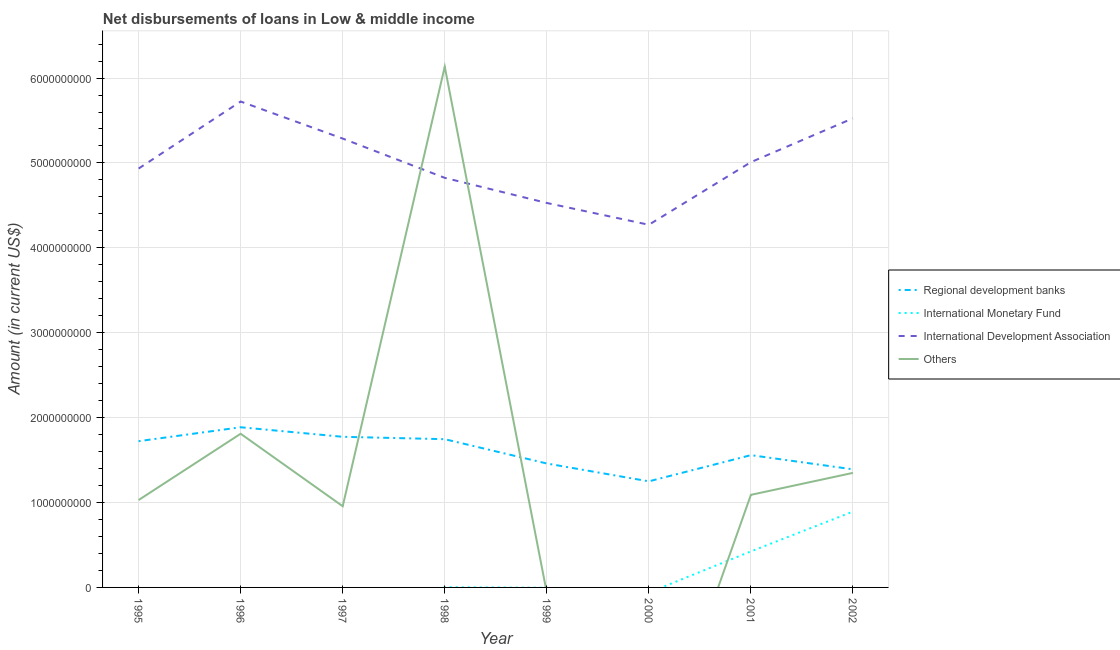How many different coloured lines are there?
Keep it short and to the point. 4. Is the number of lines equal to the number of legend labels?
Make the answer very short. No. What is the amount of loan disimbursed by regional development banks in 1995?
Make the answer very short. 1.72e+09. Across all years, what is the maximum amount of loan disimbursed by regional development banks?
Provide a short and direct response. 1.89e+09. Across all years, what is the minimum amount of loan disimbursed by other organisations?
Your answer should be compact. 0. What is the total amount of loan disimbursed by regional development banks in the graph?
Offer a terse response. 1.28e+1. What is the difference between the amount of loan disimbursed by regional development banks in 1995 and that in 1996?
Offer a very short reply. -1.64e+08. What is the difference between the amount of loan disimbursed by international development association in 2001 and the amount of loan disimbursed by international monetary fund in 1998?
Provide a succinct answer. 5.01e+09. What is the average amount of loan disimbursed by regional development banks per year?
Offer a very short reply. 1.60e+09. In the year 2002, what is the difference between the amount of loan disimbursed by international development association and amount of loan disimbursed by international monetary fund?
Ensure brevity in your answer.  4.63e+09. What is the ratio of the amount of loan disimbursed by international development association in 1998 to that in 2002?
Make the answer very short. 0.87. What is the difference between the highest and the second highest amount of loan disimbursed by international monetary fund?
Give a very brief answer. 4.69e+08. What is the difference between the highest and the lowest amount of loan disimbursed by international monetary fund?
Keep it short and to the point. 8.93e+08. Does the amount of loan disimbursed by international development association monotonically increase over the years?
Keep it short and to the point. No. Is the amount of loan disimbursed by regional development banks strictly greater than the amount of loan disimbursed by international development association over the years?
Your answer should be very brief. No. Is the amount of loan disimbursed by regional development banks strictly less than the amount of loan disimbursed by international monetary fund over the years?
Give a very brief answer. No. How many lines are there?
Offer a very short reply. 4. What is the difference between two consecutive major ticks on the Y-axis?
Your response must be concise. 1.00e+09. Are the values on the major ticks of Y-axis written in scientific E-notation?
Offer a terse response. No. How are the legend labels stacked?
Your answer should be very brief. Vertical. What is the title of the graph?
Ensure brevity in your answer.  Net disbursements of loans in Low & middle income. Does "Japan" appear as one of the legend labels in the graph?
Offer a terse response. No. What is the label or title of the X-axis?
Provide a succinct answer. Year. What is the label or title of the Y-axis?
Your answer should be very brief. Amount (in current US$). What is the Amount (in current US$) of Regional development banks in 1995?
Offer a very short reply. 1.72e+09. What is the Amount (in current US$) in International Monetary Fund in 1995?
Keep it short and to the point. 0. What is the Amount (in current US$) in International Development Association in 1995?
Your response must be concise. 4.93e+09. What is the Amount (in current US$) of Others in 1995?
Your answer should be compact. 1.03e+09. What is the Amount (in current US$) of Regional development banks in 1996?
Keep it short and to the point. 1.89e+09. What is the Amount (in current US$) of International Development Association in 1996?
Offer a terse response. 5.72e+09. What is the Amount (in current US$) of Others in 1996?
Your answer should be very brief. 1.81e+09. What is the Amount (in current US$) in Regional development banks in 1997?
Your response must be concise. 1.77e+09. What is the Amount (in current US$) in International Monetary Fund in 1997?
Give a very brief answer. 0. What is the Amount (in current US$) of International Development Association in 1997?
Ensure brevity in your answer.  5.29e+09. What is the Amount (in current US$) in Others in 1997?
Your answer should be compact. 9.57e+08. What is the Amount (in current US$) in Regional development banks in 1998?
Keep it short and to the point. 1.75e+09. What is the Amount (in current US$) of International Monetary Fund in 1998?
Give a very brief answer. 2.32e+06. What is the Amount (in current US$) in International Development Association in 1998?
Your answer should be very brief. 4.82e+09. What is the Amount (in current US$) in Others in 1998?
Your response must be concise. 6.13e+09. What is the Amount (in current US$) of Regional development banks in 1999?
Give a very brief answer. 1.46e+09. What is the Amount (in current US$) of International Development Association in 1999?
Offer a very short reply. 4.53e+09. What is the Amount (in current US$) in Others in 1999?
Offer a terse response. 0. What is the Amount (in current US$) in Regional development banks in 2000?
Your answer should be very brief. 1.25e+09. What is the Amount (in current US$) in International Development Association in 2000?
Offer a very short reply. 4.27e+09. What is the Amount (in current US$) of Regional development banks in 2001?
Your response must be concise. 1.56e+09. What is the Amount (in current US$) of International Monetary Fund in 2001?
Provide a succinct answer. 4.24e+08. What is the Amount (in current US$) of International Development Association in 2001?
Your answer should be very brief. 5.01e+09. What is the Amount (in current US$) of Others in 2001?
Provide a succinct answer. 1.09e+09. What is the Amount (in current US$) in Regional development banks in 2002?
Give a very brief answer. 1.39e+09. What is the Amount (in current US$) of International Monetary Fund in 2002?
Offer a very short reply. 8.93e+08. What is the Amount (in current US$) in International Development Association in 2002?
Offer a very short reply. 5.53e+09. What is the Amount (in current US$) in Others in 2002?
Provide a succinct answer. 1.35e+09. Across all years, what is the maximum Amount (in current US$) of Regional development banks?
Offer a very short reply. 1.89e+09. Across all years, what is the maximum Amount (in current US$) in International Monetary Fund?
Keep it short and to the point. 8.93e+08. Across all years, what is the maximum Amount (in current US$) in International Development Association?
Your answer should be very brief. 5.72e+09. Across all years, what is the maximum Amount (in current US$) in Others?
Your answer should be compact. 6.13e+09. Across all years, what is the minimum Amount (in current US$) in Regional development banks?
Make the answer very short. 1.25e+09. Across all years, what is the minimum Amount (in current US$) of International Monetary Fund?
Your response must be concise. 0. Across all years, what is the minimum Amount (in current US$) of International Development Association?
Make the answer very short. 4.27e+09. What is the total Amount (in current US$) of Regional development banks in the graph?
Ensure brevity in your answer.  1.28e+1. What is the total Amount (in current US$) of International Monetary Fund in the graph?
Make the answer very short. 1.32e+09. What is the total Amount (in current US$) in International Development Association in the graph?
Make the answer very short. 4.01e+1. What is the total Amount (in current US$) in Others in the graph?
Offer a very short reply. 1.24e+1. What is the difference between the Amount (in current US$) in Regional development banks in 1995 and that in 1996?
Provide a succinct answer. -1.64e+08. What is the difference between the Amount (in current US$) in International Development Association in 1995 and that in 1996?
Your response must be concise. -7.90e+08. What is the difference between the Amount (in current US$) of Others in 1995 and that in 1996?
Your answer should be compact. -7.81e+08. What is the difference between the Amount (in current US$) in Regional development banks in 1995 and that in 1997?
Your answer should be very brief. -5.16e+07. What is the difference between the Amount (in current US$) in International Development Association in 1995 and that in 1997?
Provide a short and direct response. -3.53e+08. What is the difference between the Amount (in current US$) of Others in 1995 and that in 1997?
Provide a succinct answer. 7.27e+07. What is the difference between the Amount (in current US$) in Regional development banks in 1995 and that in 1998?
Make the answer very short. -2.33e+07. What is the difference between the Amount (in current US$) of International Development Association in 1995 and that in 1998?
Provide a short and direct response. 1.09e+08. What is the difference between the Amount (in current US$) in Others in 1995 and that in 1998?
Make the answer very short. -5.11e+09. What is the difference between the Amount (in current US$) in Regional development banks in 1995 and that in 1999?
Give a very brief answer. 2.63e+08. What is the difference between the Amount (in current US$) in International Development Association in 1995 and that in 1999?
Give a very brief answer. 4.05e+08. What is the difference between the Amount (in current US$) in Regional development banks in 1995 and that in 2000?
Offer a terse response. 4.73e+08. What is the difference between the Amount (in current US$) in International Development Association in 1995 and that in 2000?
Your response must be concise. 6.62e+08. What is the difference between the Amount (in current US$) of Regional development banks in 1995 and that in 2001?
Give a very brief answer. 1.65e+08. What is the difference between the Amount (in current US$) in International Development Association in 1995 and that in 2001?
Your response must be concise. -7.55e+07. What is the difference between the Amount (in current US$) of Others in 1995 and that in 2001?
Provide a succinct answer. -6.12e+07. What is the difference between the Amount (in current US$) of Regional development banks in 1995 and that in 2002?
Your answer should be very brief. 3.32e+08. What is the difference between the Amount (in current US$) of International Development Association in 1995 and that in 2002?
Make the answer very short. -5.92e+08. What is the difference between the Amount (in current US$) of Others in 1995 and that in 2002?
Offer a very short reply. -3.20e+08. What is the difference between the Amount (in current US$) in Regional development banks in 1996 and that in 1997?
Offer a terse response. 1.12e+08. What is the difference between the Amount (in current US$) of International Development Association in 1996 and that in 1997?
Provide a short and direct response. 4.36e+08. What is the difference between the Amount (in current US$) in Others in 1996 and that in 1997?
Your answer should be compact. 8.54e+08. What is the difference between the Amount (in current US$) in Regional development banks in 1996 and that in 1998?
Offer a very short reply. 1.41e+08. What is the difference between the Amount (in current US$) of International Development Association in 1996 and that in 1998?
Offer a terse response. 8.99e+08. What is the difference between the Amount (in current US$) in Others in 1996 and that in 1998?
Offer a very short reply. -4.32e+09. What is the difference between the Amount (in current US$) in Regional development banks in 1996 and that in 1999?
Your response must be concise. 4.27e+08. What is the difference between the Amount (in current US$) in International Development Association in 1996 and that in 1999?
Give a very brief answer. 1.20e+09. What is the difference between the Amount (in current US$) in Regional development banks in 1996 and that in 2000?
Provide a short and direct response. 6.37e+08. What is the difference between the Amount (in current US$) in International Development Association in 1996 and that in 2000?
Your answer should be very brief. 1.45e+09. What is the difference between the Amount (in current US$) of Regional development banks in 1996 and that in 2001?
Offer a terse response. 3.28e+08. What is the difference between the Amount (in current US$) of International Development Association in 1996 and that in 2001?
Offer a very short reply. 7.14e+08. What is the difference between the Amount (in current US$) in Others in 1996 and that in 2001?
Offer a very short reply. 7.20e+08. What is the difference between the Amount (in current US$) in Regional development banks in 1996 and that in 2002?
Give a very brief answer. 4.96e+08. What is the difference between the Amount (in current US$) in International Development Association in 1996 and that in 2002?
Give a very brief answer. 1.98e+08. What is the difference between the Amount (in current US$) in Others in 1996 and that in 2002?
Your answer should be very brief. 4.61e+08. What is the difference between the Amount (in current US$) in Regional development banks in 1997 and that in 1998?
Your response must be concise. 2.83e+07. What is the difference between the Amount (in current US$) in International Development Association in 1997 and that in 1998?
Offer a very short reply. 4.63e+08. What is the difference between the Amount (in current US$) in Others in 1997 and that in 1998?
Offer a very short reply. -5.18e+09. What is the difference between the Amount (in current US$) of Regional development banks in 1997 and that in 1999?
Ensure brevity in your answer.  3.14e+08. What is the difference between the Amount (in current US$) of International Development Association in 1997 and that in 1999?
Your answer should be very brief. 7.59e+08. What is the difference between the Amount (in current US$) of Regional development banks in 1997 and that in 2000?
Give a very brief answer. 5.25e+08. What is the difference between the Amount (in current US$) in International Development Association in 1997 and that in 2000?
Provide a succinct answer. 1.02e+09. What is the difference between the Amount (in current US$) in Regional development banks in 1997 and that in 2001?
Your response must be concise. 2.16e+08. What is the difference between the Amount (in current US$) of International Development Association in 1997 and that in 2001?
Give a very brief answer. 2.78e+08. What is the difference between the Amount (in current US$) in Others in 1997 and that in 2001?
Keep it short and to the point. -1.34e+08. What is the difference between the Amount (in current US$) in Regional development banks in 1997 and that in 2002?
Ensure brevity in your answer.  3.83e+08. What is the difference between the Amount (in current US$) in International Development Association in 1997 and that in 2002?
Give a very brief answer. -2.39e+08. What is the difference between the Amount (in current US$) in Others in 1997 and that in 2002?
Your answer should be very brief. -3.93e+08. What is the difference between the Amount (in current US$) in Regional development banks in 1998 and that in 1999?
Keep it short and to the point. 2.86e+08. What is the difference between the Amount (in current US$) of International Development Association in 1998 and that in 1999?
Provide a succinct answer. 2.96e+08. What is the difference between the Amount (in current US$) in Regional development banks in 1998 and that in 2000?
Your answer should be compact. 4.96e+08. What is the difference between the Amount (in current US$) of International Development Association in 1998 and that in 2000?
Provide a short and direct response. 5.53e+08. What is the difference between the Amount (in current US$) in Regional development banks in 1998 and that in 2001?
Your response must be concise. 1.88e+08. What is the difference between the Amount (in current US$) in International Monetary Fund in 1998 and that in 2001?
Your response must be concise. -4.22e+08. What is the difference between the Amount (in current US$) of International Development Association in 1998 and that in 2001?
Your response must be concise. -1.85e+08. What is the difference between the Amount (in current US$) of Others in 1998 and that in 2001?
Make the answer very short. 5.04e+09. What is the difference between the Amount (in current US$) of Regional development banks in 1998 and that in 2002?
Make the answer very short. 3.55e+08. What is the difference between the Amount (in current US$) in International Monetary Fund in 1998 and that in 2002?
Ensure brevity in your answer.  -8.91e+08. What is the difference between the Amount (in current US$) in International Development Association in 1998 and that in 2002?
Keep it short and to the point. -7.01e+08. What is the difference between the Amount (in current US$) in Others in 1998 and that in 2002?
Your response must be concise. 4.79e+09. What is the difference between the Amount (in current US$) in Regional development banks in 1999 and that in 2000?
Ensure brevity in your answer.  2.10e+08. What is the difference between the Amount (in current US$) in International Development Association in 1999 and that in 2000?
Provide a short and direct response. 2.57e+08. What is the difference between the Amount (in current US$) in Regional development banks in 1999 and that in 2001?
Offer a terse response. -9.83e+07. What is the difference between the Amount (in current US$) of International Development Association in 1999 and that in 2001?
Offer a terse response. -4.81e+08. What is the difference between the Amount (in current US$) of Regional development banks in 1999 and that in 2002?
Make the answer very short. 6.87e+07. What is the difference between the Amount (in current US$) in International Development Association in 1999 and that in 2002?
Make the answer very short. -9.97e+08. What is the difference between the Amount (in current US$) in Regional development banks in 2000 and that in 2001?
Provide a short and direct response. -3.09e+08. What is the difference between the Amount (in current US$) in International Development Association in 2000 and that in 2001?
Provide a succinct answer. -7.38e+08. What is the difference between the Amount (in current US$) in Regional development banks in 2000 and that in 2002?
Provide a succinct answer. -1.42e+08. What is the difference between the Amount (in current US$) of International Development Association in 2000 and that in 2002?
Your response must be concise. -1.25e+09. What is the difference between the Amount (in current US$) in Regional development banks in 2001 and that in 2002?
Provide a short and direct response. 1.67e+08. What is the difference between the Amount (in current US$) of International Monetary Fund in 2001 and that in 2002?
Offer a terse response. -4.69e+08. What is the difference between the Amount (in current US$) in International Development Association in 2001 and that in 2002?
Give a very brief answer. -5.16e+08. What is the difference between the Amount (in current US$) of Others in 2001 and that in 2002?
Your answer should be very brief. -2.59e+08. What is the difference between the Amount (in current US$) in Regional development banks in 1995 and the Amount (in current US$) in International Development Association in 1996?
Keep it short and to the point. -4.00e+09. What is the difference between the Amount (in current US$) in Regional development banks in 1995 and the Amount (in current US$) in Others in 1996?
Your response must be concise. -8.76e+07. What is the difference between the Amount (in current US$) of International Development Association in 1995 and the Amount (in current US$) of Others in 1996?
Provide a succinct answer. 3.12e+09. What is the difference between the Amount (in current US$) in Regional development banks in 1995 and the Amount (in current US$) in International Development Association in 1997?
Give a very brief answer. -3.56e+09. What is the difference between the Amount (in current US$) in Regional development banks in 1995 and the Amount (in current US$) in Others in 1997?
Your answer should be compact. 7.66e+08. What is the difference between the Amount (in current US$) of International Development Association in 1995 and the Amount (in current US$) of Others in 1997?
Keep it short and to the point. 3.98e+09. What is the difference between the Amount (in current US$) of Regional development banks in 1995 and the Amount (in current US$) of International Monetary Fund in 1998?
Your response must be concise. 1.72e+09. What is the difference between the Amount (in current US$) in Regional development banks in 1995 and the Amount (in current US$) in International Development Association in 1998?
Your answer should be compact. -3.10e+09. What is the difference between the Amount (in current US$) of Regional development banks in 1995 and the Amount (in current US$) of Others in 1998?
Offer a very short reply. -4.41e+09. What is the difference between the Amount (in current US$) in International Development Association in 1995 and the Amount (in current US$) in Others in 1998?
Ensure brevity in your answer.  -1.20e+09. What is the difference between the Amount (in current US$) of Regional development banks in 1995 and the Amount (in current US$) of International Development Association in 1999?
Give a very brief answer. -2.81e+09. What is the difference between the Amount (in current US$) of Regional development banks in 1995 and the Amount (in current US$) of International Development Association in 2000?
Provide a succinct answer. -2.55e+09. What is the difference between the Amount (in current US$) of Regional development banks in 1995 and the Amount (in current US$) of International Monetary Fund in 2001?
Provide a short and direct response. 1.30e+09. What is the difference between the Amount (in current US$) of Regional development banks in 1995 and the Amount (in current US$) of International Development Association in 2001?
Make the answer very short. -3.29e+09. What is the difference between the Amount (in current US$) of Regional development banks in 1995 and the Amount (in current US$) of Others in 2001?
Your answer should be compact. 6.32e+08. What is the difference between the Amount (in current US$) in International Development Association in 1995 and the Amount (in current US$) in Others in 2001?
Your answer should be very brief. 3.84e+09. What is the difference between the Amount (in current US$) in Regional development banks in 1995 and the Amount (in current US$) in International Monetary Fund in 2002?
Provide a short and direct response. 8.29e+08. What is the difference between the Amount (in current US$) of Regional development banks in 1995 and the Amount (in current US$) of International Development Association in 2002?
Keep it short and to the point. -3.80e+09. What is the difference between the Amount (in current US$) in Regional development banks in 1995 and the Amount (in current US$) in Others in 2002?
Make the answer very short. 3.73e+08. What is the difference between the Amount (in current US$) in International Development Association in 1995 and the Amount (in current US$) in Others in 2002?
Offer a terse response. 3.58e+09. What is the difference between the Amount (in current US$) of Regional development banks in 1996 and the Amount (in current US$) of International Development Association in 1997?
Offer a very short reply. -3.40e+09. What is the difference between the Amount (in current US$) of Regional development banks in 1996 and the Amount (in current US$) of Others in 1997?
Make the answer very short. 9.30e+08. What is the difference between the Amount (in current US$) in International Development Association in 1996 and the Amount (in current US$) in Others in 1997?
Provide a short and direct response. 4.77e+09. What is the difference between the Amount (in current US$) in Regional development banks in 1996 and the Amount (in current US$) in International Monetary Fund in 1998?
Your response must be concise. 1.88e+09. What is the difference between the Amount (in current US$) in Regional development banks in 1996 and the Amount (in current US$) in International Development Association in 1998?
Keep it short and to the point. -2.94e+09. What is the difference between the Amount (in current US$) of Regional development banks in 1996 and the Amount (in current US$) of Others in 1998?
Provide a short and direct response. -4.25e+09. What is the difference between the Amount (in current US$) of International Development Association in 1996 and the Amount (in current US$) of Others in 1998?
Offer a very short reply. -4.11e+08. What is the difference between the Amount (in current US$) of Regional development banks in 1996 and the Amount (in current US$) of International Development Association in 1999?
Keep it short and to the point. -2.64e+09. What is the difference between the Amount (in current US$) in Regional development banks in 1996 and the Amount (in current US$) in International Development Association in 2000?
Provide a short and direct response. -2.39e+09. What is the difference between the Amount (in current US$) in Regional development banks in 1996 and the Amount (in current US$) in International Monetary Fund in 2001?
Your answer should be compact. 1.46e+09. What is the difference between the Amount (in current US$) of Regional development banks in 1996 and the Amount (in current US$) of International Development Association in 2001?
Make the answer very short. -3.12e+09. What is the difference between the Amount (in current US$) in Regional development banks in 1996 and the Amount (in current US$) in Others in 2001?
Your answer should be compact. 7.96e+08. What is the difference between the Amount (in current US$) in International Development Association in 1996 and the Amount (in current US$) in Others in 2001?
Give a very brief answer. 4.63e+09. What is the difference between the Amount (in current US$) of Regional development banks in 1996 and the Amount (in current US$) of International Monetary Fund in 2002?
Offer a very short reply. 9.93e+08. What is the difference between the Amount (in current US$) in Regional development banks in 1996 and the Amount (in current US$) in International Development Association in 2002?
Provide a succinct answer. -3.64e+09. What is the difference between the Amount (in current US$) of Regional development banks in 1996 and the Amount (in current US$) of Others in 2002?
Offer a very short reply. 5.37e+08. What is the difference between the Amount (in current US$) in International Development Association in 1996 and the Amount (in current US$) in Others in 2002?
Your answer should be very brief. 4.37e+09. What is the difference between the Amount (in current US$) of Regional development banks in 1997 and the Amount (in current US$) of International Monetary Fund in 1998?
Give a very brief answer. 1.77e+09. What is the difference between the Amount (in current US$) in Regional development banks in 1997 and the Amount (in current US$) in International Development Association in 1998?
Keep it short and to the point. -3.05e+09. What is the difference between the Amount (in current US$) in Regional development banks in 1997 and the Amount (in current US$) in Others in 1998?
Offer a very short reply. -4.36e+09. What is the difference between the Amount (in current US$) in International Development Association in 1997 and the Amount (in current US$) in Others in 1998?
Keep it short and to the point. -8.47e+08. What is the difference between the Amount (in current US$) in Regional development banks in 1997 and the Amount (in current US$) in International Development Association in 1999?
Offer a very short reply. -2.75e+09. What is the difference between the Amount (in current US$) of Regional development banks in 1997 and the Amount (in current US$) of International Development Association in 2000?
Your answer should be compact. -2.50e+09. What is the difference between the Amount (in current US$) of Regional development banks in 1997 and the Amount (in current US$) of International Monetary Fund in 2001?
Your answer should be compact. 1.35e+09. What is the difference between the Amount (in current US$) of Regional development banks in 1997 and the Amount (in current US$) of International Development Association in 2001?
Give a very brief answer. -3.24e+09. What is the difference between the Amount (in current US$) in Regional development banks in 1997 and the Amount (in current US$) in Others in 2001?
Keep it short and to the point. 6.84e+08. What is the difference between the Amount (in current US$) of International Development Association in 1997 and the Amount (in current US$) of Others in 2001?
Give a very brief answer. 4.20e+09. What is the difference between the Amount (in current US$) of Regional development banks in 1997 and the Amount (in current US$) of International Monetary Fund in 2002?
Offer a terse response. 8.81e+08. What is the difference between the Amount (in current US$) of Regional development banks in 1997 and the Amount (in current US$) of International Development Association in 2002?
Offer a terse response. -3.75e+09. What is the difference between the Amount (in current US$) of Regional development banks in 1997 and the Amount (in current US$) of Others in 2002?
Provide a short and direct response. 4.25e+08. What is the difference between the Amount (in current US$) of International Development Association in 1997 and the Amount (in current US$) of Others in 2002?
Provide a short and direct response. 3.94e+09. What is the difference between the Amount (in current US$) in Regional development banks in 1998 and the Amount (in current US$) in International Development Association in 1999?
Give a very brief answer. -2.78e+09. What is the difference between the Amount (in current US$) of International Monetary Fund in 1998 and the Amount (in current US$) of International Development Association in 1999?
Ensure brevity in your answer.  -4.53e+09. What is the difference between the Amount (in current US$) in Regional development banks in 1998 and the Amount (in current US$) in International Development Association in 2000?
Give a very brief answer. -2.53e+09. What is the difference between the Amount (in current US$) in International Monetary Fund in 1998 and the Amount (in current US$) in International Development Association in 2000?
Offer a terse response. -4.27e+09. What is the difference between the Amount (in current US$) of Regional development banks in 1998 and the Amount (in current US$) of International Monetary Fund in 2001?
Your answer should be compact. 1.32e+09. What is the difference between the Amount (in current US$) of Regional development banks in 1998 and the Amount (in current US$) of International Development Association in 2001?
Offer a terse response. -3.26e+09. What is the difference between the Amount (in current US$) in Regional development banks in 1998 and the Amount (in current US$) in Others in 2001?
Your response must be concise. 6.56e+08. What is the difference between the Amount (in current US$) of International Monetary Fund in 1998 and the Amount (in current US$) of International Development Association in 2001?
Provide a short and direct response. -5.01e+09. What is the difference between the Amount (in current US$) of International Monetary Fund in 1998 and the Amount (in current US$) of Others in 2001?
Your response must be concise. -1.09e+09. What is the difference between the Amount (in current US$) of International Development Association in 1998 and the Amount (in current US$) of Others in 2001?
Provide a short and direct response. 3.73e+09. What is the difference between the Amount (in current US$) of Regional development banks in 1998 and the Amount (in current US$) of International Monetary Fund in 2002?
Your response must be concise. 8.53e+08. What is the difference between the Amount (in current US$) of Regional development banks in 1998 and the Amount (in current US$) of International Development Association in 2002?
Give a very brief answer. -3.78e+09. What is the difference between the Amount (in current US$) of Regional development banks in 1998 and the Amount (in current US$) of Others in 2002?
Provide a short and direct response. 3.97e+08. What is the difference between the Amount (in current US$) of International Monetary Fund in 1998 and the Amount (in current US$) of International Development Association in 2002?
Keep it short and to the point. -5.52e+09. What is the difference between the Amount (in current US$) in International Monetary Fund in 1998 and the Amount (in current US$) in Others in 2002?
Your answer should be very brief. -1.35e+09. What is the difference between the Amount (in current US$) of International Development Association in 1998 and the Amount (in current US$) of Others in 2002?
Provide a succinct answer. 3.48e+09. What is the difference between the Amount (in current US$) in Regional development banks in 1999 and the Amount (in current US$) in International Development Association in 2000?
Your answer should be compact. -2.81e+09. What is the difference between the Amount (in current US$) in Regional development banks in 1999 and the Amount (in current US$) in International Monetary Fund in 2001?
Give a very brief answer. 1.04e+09. What is the difference between the Amount (in current US$) in Regional development banks in 1999 and the Amount (in current US$) in International Development Association in 2001?
Provide a succinct answer. -3.55e+09. What is the difference between the Amount (in current US$) in Regional development banks in 1999 and the Amount (in current US$) in Others in 2001?
Your response must be concise. 3.69e+08. What is the difference between the Amount (in current US$) in International Development Association in 1999 and the Amount (in current US$) in Others in 2001?
Ensure brevity in your answer.  3.44e+09. What is the difference between the Amount (in current US$) of Regional development banks in 1999 and the Amount (in current US$) of International Monetary Fund in 2002?
Ensure brevity in your answer.  5.66e+08. What is the difference between the Amount (in current US$) in Regional development banks in 1999 and the Amount (in current US$) in International Development Association in 2002?
Give a very brief answer. -4.07e+09. What is the difference between the Amount (in current US$) in Regional development banks in 1999 and the Amount (in current US$) in Others in 2002?
Offer a terse response. 1.11e+08. What is the difference between the Amount (in current US$) of International Development Association in 1999 and the Amount (in current US$) of Others in 2002?
Your answer should be compact. 3.18e+09. What is the difference between the Amount (in current US$) in Regional development banks in 2000 and the Amount (in current US$) in International Monetary Fund in 2001?
Ensure brevity in your answer.  8.25e+08. What is the difference between the Amount (in current US$) of Regional development banks in 2000 and the Amount (in current US$) of International Development Association in 2001?
Ensure brevity in your answer.  -3.76e+09. What is the difference between the Amount (in current US$) in Regional development banks in 2000 and the Amount (in current US$) in Others in 2001?
Make the answer very short. 1.59e+08. What is the difference between the Amount (in current US$) of International Development Association in 2000 and the Amount (in current US$) of Others in 2001?
Make the answer very short. 3.18e+09. What is the difference between the Amount (in current US$) in Regional development banks in 2000 and the Amount (in current US$) in International Monetary Fund in 2002?
Keep it short and to the point. 3.56e+08. What is the difference between the Amount (in current US$) in Regional development banks in 2000 and the Amount (in current US$) in International Development Association in 2002?
Your response must be concise. -4.28e+09. What is the difference between the Amount (in current US$) of Regional development banks in 2000 and the Amount (in current US$) of Others in 2002?
Offer a very short reply. -9.97e+07. What is the difference between the Amount (in current US$) of International Development Association in 2000 and the Amount (in current US$) of Others in 2002?
Provide a short and direct response. 2.92e+09. What is the difference between the Amount (in current US$) of Regional development banks in 2001 and the Amount (in current US$) of International Monetary Fund in 2002?
Your answer should be compact. 6.65e+08. What is the difference between the Amount (in current US$) of Regional development banks in 2001 and the Amount (in current US$) of International Development Association in 2002?
Your answer should be very brief. -3.97e+09. What is the difference between the Amount (in current US$) of Regional development banks in 2001 and the Amount (in current US$) of Others in 2002?
Provide a succinct answer. 2.09e+08. What is the difference between the Amount (in current US$) in International Monetary Fund in 2001 and the Amount (in current US$) in International Development Association in 2002?
Offer a terse response. -5.10e+09. What is the difference between the Amount (in current US$) of International Monetary Fund in 2001 and the Amount (in current US$) of Others in 2002?
Give a very brief answer. -9.25e+08. What is the difference between the Amount (in current US$) of International Development Association in 2001 and the Amount (in current US$) of Others in 2002?
Make the answer very short. 3.66e+09. What is the average Amount (in current US$) of Regional development banks per year?
Ensure brevity in your answer.  1.60e+09. What is the average Amount (in current US$) of International Monetary Fund per year?
Provide a short and direct response. 1.65e+08. What is the average Amount (in current US$) of International Development Association per year?
Ensure brevity in your answer.  5.01e+09. What is the average Amount (in current US$) of Others per year?
Make the answer very short. 1.55e+09. In the year 1995, what is the difference between the Amount (in current US$) in Regional development banks and Amount (in current US$) in International Development Association?
Offer a terse response. -3.21e+09. In the year 1995, what is the difference between the Amount (in current US$) of Regional development banks and Amount (in current US$) of Others?
Keep it short and to the point. 6.93e+08. In the year 1995, what is the difference between the Amount (in current US$) in International Development Association and Amount (in current US$) in Others?
Your response must be concise. 3.90e+09. In the year 1996, what is the difference between the Amount (in current US$) of Regional development banks and Amount (in current US$) of International Development Association?
Your answer should be very brief. -3.84e+09. In the year 1996, what is the difference between the Amount (in current US$) of Regional development banks and Amount (in current US$) of Others?
Offer a terse response. 7.64e+07. In the year 1996, what is the difference between the Amount (in current US$) in International Development Association and Amount (in current US$) in Others?
Provide a succinct answer. 3.91e+09. In the year 1997, what is the difference between the Amount (in current US$) of Regional development banks and Amount (in current US$) of International Development Association?
Give a very brief answer. -3.51e+09. In the year 1997, what is the difference between the Amount (in current US$) of Regional development banks and Amount (in current US$) of Others?
Your answer should be very brief. 8.18e+08. In the year 1997, what is the difference between the Amount (in current US$) in International Development Association and Amount (in current US$) in Others?
Give a very brief answer. 4.33e+09. In the year 1998, what is the difference between the Amount (in current US$) of Regional development banks and Amount (in current US$) of International Monetary Fund?
Offer a very short reply. 1.74e+09. In the year 1998, what is the difference between the Amount (in current US$) in Regional development banks and Amount (in current US$) in International Development Association?
Provide a short and direct response. -3.08e+09. In the year 1998, what is the difference between the Amount (in current US$) of Regional development banks and Amount (in current US$) of Others?
Your answer should be very brief. -4.39e+09. In the year 1998, what is the difference between the Amount (in current US$) in International Monetary Fund and Amount (in current US$) in International Development Association?
Offer a terse response. -4.82e+09. In the year 1998, what is the difference between the Amount (in current US$) in International Monetary Fund and Amount (in current US$) in Others?
Provide a succinct answer. -6.13e+09. In the year 1998, what is the difference between the Amount (in current US$) of International Development Association and Amount (in current US$) of Others?
Give a very brief answer. -1.31e+09. In the year 1999, what is the difference between the Amount (in current US$) in Regional development banks and Amount (in current US$) in International Development Association?
Provide a short and direct response. -3.07e+09. In the year 2000, what is the difference between the Amount (in current US$) in Regional development banks and Amount (in current US$) in International Development Association?
Keep it short and to the point. -3.02e+09. In the year 2001, what is the difference between the Amount (in current US$) in Regional development banks and Amount (in current US$) in International Monetary Fund?
Provide a succinct answer. 1.13e+09. In the year 2001, what is the difference between the Amount (in current US$) in Regional development banks and Amount (in current US$) in International Development Association?
Offer a very short reply. -3.45e+09. In the year 2001, what is the difference between the Amount (in current US$) in Regional development banks and Amount (in current US$) in Others?
Keep it short and to the point. 4.68e+08. In the year 2001, what is the difference between the Amount (in current US$) in International Monetary Fund and Amount (in current US$) in International Development Association?
Provide a succinct answer. -4.59e+09. In the year 2001, what is the difference between the Amount (in current US$) in International Monetary Fund and Amount (in current US$) in Others?
Your answer should be compact. -6.66e+08. In the year 2001, what is the difference between the Amount (in current US$) in International Development Association and Amount (in current US$) in Others?
Keep it short and to the point. 3.92e+09. In the year 2002, what is the difference between the Amount (in current US$) in Regional development banks and Amount (in current US$) in International Monetary Fund?
Your answer should be very brief. 4.98e+08. In the year 2002, what is the difference between the Amount (in current US$) in Regional development banks and Amount (in current US$) in International Development Association?
Give a very brief answer. -4.13e+09. In the year 2002, what is the difference between the Amount (in current US$) in Regional development banks and Amount (in current US$) in Others?
Provide a short and direct response. 4.18e+07. In the year 2002, what is the difference between the Amount (in current US$) of International Monetary Fund and Amount (in current US$) of International Development Association?
Offer a very short reply. -4.63e+09. In the year 2002, what is the difference between the Amount (in current US$) in International Monetary Fund and Amount (in current US$) in Others?
Keep it short and to the point. -4.56e+08. In the year 2002, what is the difference between the Amount (in current US$) in International Development Association and Amount (in current US$) in Others?
Keep it short and to the point. 4.18e+09. What is the ratio of the Amount (in current US$) of Regional development banks in 1995 to that in 1996?
Your answer should be compact. 0.91. What is the ratio of the Amount (in current US$) in International Development Association in 1995 to that in 1996?
Offer a terse response. 0.86. What is the ratio of the Amount (in current US$) of Others in 1995 to that in 1996?
Keep it short and to the point. 0.57. What is the ratio of the Amount (in current US$) in Regional development banks in 1995 to that in 1997?
Offer a very short reply. 0.97. What is the ratio of the Amount (in current US$) of International Development Association in 1995 to that in 1997?
Your answer should be very brief. 0.93. What is the ratio of the Amount (in current US$) of Others in 1995 to that in 1997?
Offer a very short reply. 1.08. What is the ratio of the Amount (in current US$) of Regional development banks in 1995 to that in 1998?
Offer a terse response. 0.99. What is the ratio of the Amount (in current US$) of International Development Association in 1995 to that in 1998?
Make the answer very short. 1.02. What is the ratio of the Amount (in current US$) of Others in 1995 to that in 1998?
Give a very brief answer. 0.17. What is the ratio of the Amount (in current US$) of Regional development banks in 1995 to that in 1999?
Provide a short and direct response. 1.18. What is the ratio of the Amount (in current US$) of International Development Association in 1995 to that in 1999?
Give a very brief answer. 1.09. What is the ratio of the Amount (in current US$) in Regional development banks in 1995 to that in 2000?
Your answer should be very brief. 1.38. What is the ratio of the Amount (in current US$) in International Development Association in 1995 to that in 2000?
Your answer should be compact. 1.16. What is the ratio of the Amount (in current US$) in Regional development banks in 1995 to that in 2001?
Your answer should be compact. 1.11. What is the ratio of the Amount (in current US$) in International Development Association in 1995 to that in 2001?
Your answer should be compact. 0.98. What is the ratio of the Amount (in current US$) in Others in 1995 to that in 2001?
Your answer should be very brief. 0.94. What is the ratio of the Amount (in current US$) of Regional development banks in 1995 to that in 2002?
Make the answer very short. 1.24. What is the ratio of the Amount (in current US$) of International Development Association in 1995 to that in 2002?
Provide a succinct answer. 0.89. What is the ratio of the Amount (in current US$) in Others in 1995 to that in 2002?
Ensure brevity in your answer.  0.76. What is the ratio of the Amount (in current US$) in Regional development banks in 1996 to that in 1997?
Your answer should be compact. 1.06. What is the ratio of the Amount (in current US$) of International Development Association in 1996 to that in 1997?
Offer a very short reply. 1.08. What is the ratio of the Amount (in current US$) of Others in 1996 to that in 1997?
Your answer should be compact. 1.89. What is the ratio of the Amount (in current US$) of Regional development banks in 1996 to that in 1998?
Make the answer very short. 1.08. What is the ratio of the Amount (in current US$) in International Development Association in 1996 to that in 1998?
Your response must be concise. 1.19. What is the ratio of the Amount (in current US$) of Others in 1996 to that in 1998?
Your answer should be very brief. 0.3. What is the ratio of the Amount (in current US$) in Regional development banks in 1996 to that in 1999?
Your answer should be very brief. 1.29. What is the ratio of the Amount (in current US$) of International Development Association in 1996 to that in 1999?
Your response must be concise. 1.26. What is the ratio of the Amount (in current US$) of Regional development banks in 1996 to that in 2000?
Give a very brief answer. 1.51. What is the ratio of the Amount (in current US$) in International Development Association in 1996 to that in 2000?
Keep it short and to the point. 1.34. What is the ratio of the Amount (in current US$) in Regional development banks in 1996 to that in 2001?
Give a very brief answer. 1.21. What is the ratio of the Amount (in current US$) in International Development Association in 1996 to that in 2001?
Your response must be concise. 1.14. What is the ratio of the Amount (in current US$) of Others in 1996 to that in 2001?
Make the answer very short. 1.66. What is the ratio of the Amount (in current US$) in Regional development banks in 1996 to that in 2002?
Provide a succinct answer. 1.36. What is the ratio of the Amount (in current US$) in International Development Association in 1996 to that in 2002?
Your answer should be compact. 1.04. What is the ratio of the Amount (in current US$) of Others in 1996 to that in 2002?
Make the answer very short. 1.34. What is the ratio of the Amount (in current US$) of Regional development banks in 1997 to that in 1998?
Offer a very short reply. 1.02. What is the ratio of the Amount (in current US$) in International Development Association in 1997 to that in 1998?
Provide a succinct answer. 1.1. What is the ratio of the Amount (in current US$) in Others in 1997 to that in 1998?
Your answer should be very brief. 0.16. What is the ratio of the Amount (in current US$) of Regional development banks in 1997 to that in 1999?
Provide a short and direct response. 1.22. What is the ratio of the Amount (in current US$) in International Development Association in 1997 to that in 1999?
Your answer should be very brief. 1.17. What is the ratio of the Amount (in current US$) in Regional development banks in 1997 to that in 2000?
Provide a succinct answer. 1.42. What is the ratio of the Amount (in current US$) of International Development Association in 1997 to that in 2000?
Ensure brevity in your answer.  1.24. What is the ratio of the Amount (in current US$) in Regional development banks in 1997 to that in 2001?
Give a very brief answer. 1.14. What is the ratio of the Amount (in current US$) in International Development Association in 1997 to that in 2001?
Your answer should be compact. 1.06. What is the ratio of the Amount (in current US$) of Others in 1997 to that in 2001?
Keep it short and to the point. 0.88. What is the ratio of the Amount (in current US$) in Regional development banks in 1997 to that in 2002?
Your response must be concise. 1.28. What is the ratio of the Amount (in current US$) of International Development Association in 1997 to that in 2002?
Provide a short and direct response. 0.96. What is the ratio of the Amount (in current US$) of Others in 1997 to that in 2002?
Your answer should be compact. 0.71. What is the ratio of the Amount (in current US$) of Regional development banks in 1998 to that in 1999?
Your response must be concise. 1.2. What is the ratio of the Amount (in current US$) in International Development Association in 1998 to that in 1999?
Your answer should be very brief. 1.07. What is the ratio of the Amount (in current US$) in Regional development banks in 1998 to that in 2000?
Offer a terse response. 1.4. What is the ratio of the Amount (in current US$) in International Development Association in 1998 to that in 2000?
Your answer should be very brief. 1.13. What is the ratio of the Amount (in current US$) in Regional development banks in 1998 to that in 2001?
Your response must be concise. 1.12. What is the ratio of the Amount (in current US$) in International Monetary Fund in 1998 to that in 2001?
Keep it short and to the point. 0.01. What is the ratio of the Amount (in current US$) of International Development Association in 1998 to that in 2001?
Your answer should be very brief. 0.96. What is the ratio of the Amount (in current US$) in Others in 1998 to that in 2001?
Your answer should be very brief. 5.63. What is the ratio of the Amount (in current US$) of Regional development banks in 1998 to that in 2002?
Offer a terse response. 1.26. What is the ratio of the Amount (in current US$) in International Monetary Fund in 1998 to that in 2002?
Provide a succinct answer. 0. What is the ratio of the Amount (in current US$) of International Development Association in 1998 to that in 2002?
Offer a terse response. 0.87. What is the ratio of the Amount (in current US$) in Others in 1998 to that in 2002?
Your answer should be compact. 4.55. What is the ratio of the Amount (in current US$) of Regional development banks in 1999 to that in 2000?
Ensure brevity in your answer.  1.17. What is the ratio of the Amount (in current US$) in International Development Association in 1999 to that in 2000?
Your response must be concise. 1.06. What is the ratio of the Amount (in current US$) in Regional development banks in 1999 to that in 2001?
Your response must be concise. 0.94. What is the ratio of the Amount (in current US$) of International Development Association in 1999 to that in 2001?
Your answer should be very brief. 0.9. What is the ratio of the Amount (in current US$) of Regional development banks in 1999 to that in 2002?
Ensure brevity in your answer.  1.05. What is the ratio of the Amount (in current US$) of International Development Association in 1999 to that in 2002?
Ensure brevity in your answer.  0.82. What is the ratio of the Amount (in current US$) in Regional development banks in 2000 to that in 2001?
Offer a terse response. 0.8. What is the ratio of the Amount (in current US$) of International Development Association in 2000 to that in 2001?
Keep it short and to the point. 0.85. What is the ratio of the Amount (in current US$) in Regional development banks in 2000 to that in 2002?
Your answer should be very brief. 0.9. What is the ratio of the Amount (in current US$) in International Development Association in 2000 to that in 2002?
Your response must be concise. 0.77. What is the ratio of the Amount (in current US$) of Regional development banks in 2001 to that in 2002?
Provide a short and direct response. 1.12. What is the ratio of the Amount (in current US$) in International Monetary Fund in 2001 to that in 2002?
Offer a very short reply. 0.47. What is the ratio of the Amount (in current US$) of International Development Association in 2001 to that in 2002?
Give a very brief answer. 0.91. What is the ratio of the Amount (in current US$) in Others in 2001 to that in 2002?
Give a very brief answer. 0.81. What is the difference between the highest and the second highest Amount (in current US$) of Regional development banks?
Give a very brief answer. 1.12e+08. What is the difference between the highest and the second highest Amount (in current US$) in International Monetary Fund?
Your answer should be compact. 4.69e+08. What is the difference between the highest and the second highest Amount (in current US$) in International Development Association?
Your answer should be very brief. 1.98e+08. What is the difference between the highest and the second highest Amount (in current US$) of Others?
Your response must be concise. 4.32e+09. What is the difference between the highest and the lowest Amount (in current US$) in Regional development banks?
Offer a very short reply. 6.37e+08. What is the difference between the highest and the lowest Amount (in current US$) of International Monetary Fund?
Ensure brevity in your answer.  8.93e+08. What is the difference between the highest and the lowest Amount (in current US$) in International Development Association?
Offer a terse response. 1.45e+09. What is the difference between the highest and the lowest Amount (in current US$) of Others?
Provide a short and direct response. 6.13e+09. 